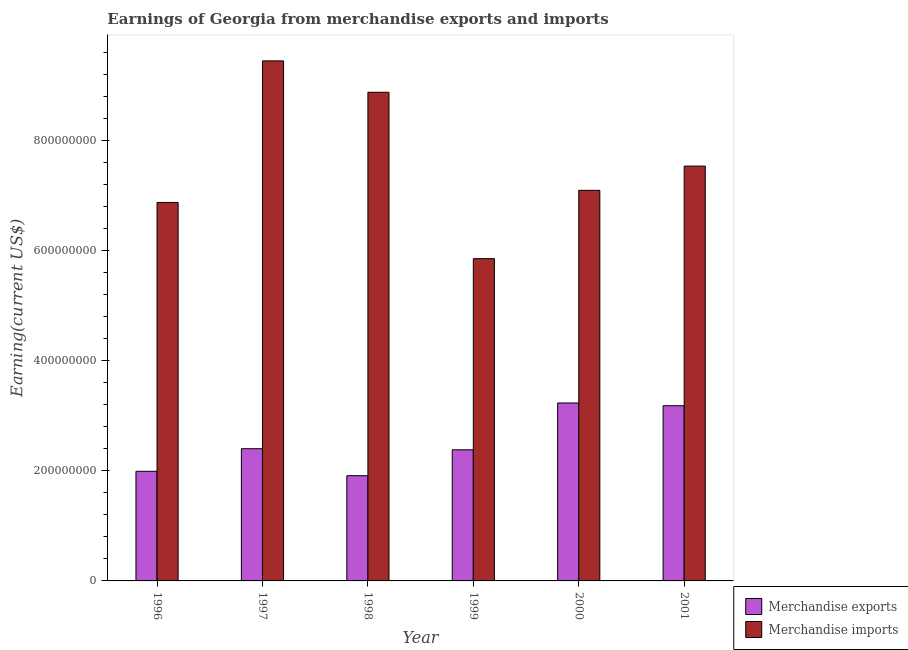How many groups of bars are there?
Offer a terse response. 6. Are the number of bars on each tick of the X-axis equal?
Your answer should be compact. Yes. How many bars are there on the 6th tick from the left?
Provide a short and direct response. 2. What is the earnings from merchandise imports in 1996?
Your response must be concise. 6.87e+08. Across all years, what is the maximum earnings from merchandise exports?
Your answer should be very brief. 3.23e+08. Across all years, what is the minimum earnings from merchandise imports?
Ensure brevity in your answer.  5.85e+08. In which year was the earnings from merchandise imports maximum?
Offer a terse response. 1997. In which year was the earnings from merchandise imports minimum?
Give a very brief answer. 1999. What is the total earnings from merchandise imports in the graph?
Your answer should be compact. 4.56e+09. What is the difference between the earnings from merchandise exports in 1999 and that in 2000?
Give a very brief answer. -8.50e+07. What is the difference between the earnings from merchandise imports in 1997 and the earnings from merchandise exports in 1999?
Your answer should be compact. 3.59e+08. What is the average earnings from merchandise imports per year?
Ensure brevity in your answer.  7.61e+08. In the year 1998, what is the difference between the earnings from merchandise imports and earnings from merchandise exports?
Provide a succinct answer. 0. In how many years, is the earnings from merchandise imports greater than 600000000 US$?
Ensure brevity in your answer.  5. What is the ratio of the earnings from merchandise imports in 1997 to that in 1999?
Your answer should be very brief. 1.61. Is the earnings from merchandise exports in 1999 less than that in 2001?
Your answer should be compact. Yes. What is the difference between the highest and the second highest earnings from merchandise imports?
Make the answer very short. 5.70e+07. What is the difference between the highest and the lowest earnings from merchandise exports?
Offer a terse response. 1.32e+08. In how many years, is the earnings from merchandise imports greater than the average earnings from merchandise imports taken over all years?
Your response must be concise. 2. How many bars are there?
Ensure brevity in your answer.  12. Are all the bars in the graph horizontal?
Provide a short and direct response. No. How many years are there in the graph?
Your answer should be compact. 6. Are the values on the major ticks of Y-axis written in scientific E-notation?
Your answer should be compact. No. How are the legend labels stacked?
Your response must be concise. Vertical. What is the title of the graph?
Offer a very short reply. Earnings of Georgia from merchandise exports and imports. What is the label or title of the X-axis?
Offer a very short reply. Year. What is the label or title of the Y-axis?
Offer a terse response. Earning(current US$). What is the Earning(current US$) of Merchandise exports in 1996?
Offer a terse response. 1.99e+08. What is the Earning(current US$) in Merchandise imports in 1996?
Keep it short and to the point. 6.87e+08. What is the Earning(current US$) of Merchandise exports in 1997?
Your response must be concise. 2.40e+08. What is the Earning(current US$) of Merchandise imports in 1997?
Keep it short and to the point. 9.44e+08. What is the Earning(current US$) in Merchandise exports in 1998?
Ensure brevity in your answer.  1.91e+08. What is the Earning(current US$) of Merchandise imports in 1998?
Make the answer very short. 8.87e+08. What is the Earning(current US$) in Merchandise exports in 1999?
Keep it short and to the point. 2.38e+08. What is the Earning(current US$) of Merchandise imports in 1999?
Give a very brief answer. 5.85e+08. What is the Earning(current US$) in Merchandise exports in 2000?
Ensure brevity in your answer.  3.23e+08. What is the Earning(current US$) in Merchandise imports in 2000?
Keep it short and to the point. 7.09e+08. What is the Earning(current US$) of Merchandise exports in 2001?
Ensure brevity in your answer.  3.18e+08. What is the Earning(current US$) of Merchandise imports in 2001?
Provide a succinct answer. 7.53e+08. Across all years, what is the maximum Earning(current US$) in Merchandise exports?
Keep it short and to the point. 3.23e+08. Across all years, what is the maximum Earning(current US$) of Merchandise imports?
Your response must be concise. 9.44e+08. Across all years, what is the minimum Earning(current US$) of Merchandise exports?
Make the answer very short. 1.91e+08. Across all years, what is the minimum Earning(current US$) of Merchandise imports?
Your answer should be very brief. 5.85e+08. What is the total Earning(current US$) of Merchandise exports in the graph?
Provide a short and direct response. 1.51e+09. What is the total Earning(current US$) in Merchandise imports in the graph?
Offer a terse response. 4.56e+09. What is the difference between the Earning(current US$) in Merchandise exports in 1996 and that in 1997?
Make the answer very short. -4.10e+07. What is the difference between the Earning(current US$) of Merchandise imports in 1996 and that in 1997?
Your answer should be compact. -2.57e+08. What is the difference between the Earning(current US$) in Merchandise exports in 1996 and that in 1998?
Give a very brief answer. 8.00e+06. What is the difference between the Earning(current US$) in Merchandise imports in 1996 and that in 1998?
Offer a very short reply. -2.00e+08. What is the difference between the Earning(current US$) of Merchandise exports in 1996 and that in 1999?
Offer a very short reply. -3.90e+07. What is the difference between the Earning(current US$) of Merchandise imports in 1996 and that in 1999?
Provide a short and direct response. 1.02e+08. What is the difference between the Earning(current US$) in Merchandise exports in 1996 and that in 2000?
Ensure brevity in your answer.  -1.24e+08. What is the difference between the Earning(current US$) of Merchandise imports in 1996 and that in 2000?
Offer a terse response. -2.20e+07. What is the difference between the Earning(current US$) in Merchandise exports in 1996 and that in 2001?
Your answer should be compact. -1.19e+08. What is the difference between the Earning(current US$) in Merchandise imports in 1996 and that in 2001?
Your response must be concise. -6.60e+07. What is the difference between the Earning(current US$) of Merchandise exports in 1997 and that in 1998?
Your answer should be compact. 4.90e+07. What is the difference between the Earning(current US$) of Merchandise imports in 1997 and that in 1998?
Your answer should be compact. 5.70e+07. What is the difference between the Earning(current US$) in Merchandise exports in 1997 and that in 1999?
Your answer should be very brief. 2.00e+06. What is the difference between the Earning(current US$) in Merchandise imports in 1997 and that in 1999?
Your answer should be very brief. 3.59e+08. What is the difference between the Earning(current US$) of Merchandise exports in 1997 and that in 2000?
Make the answer very short. -8.30e+07. What is the difference between the Earning(current US$) in Merchandise imports in 1997 and that in 2000?
Offer a terse response. 2.35e+08. What is the difference between the Earning(current US$) of Merchandise exports in 1997 and that in 2001?
Provide a short and direct response. -7.80e+07. What is the difference between the Earning(current US$) in Merchandise imports in 1997 and that in 2001?
Offer a terse response. 1.91e+08. What is the difference between the Earning(current US$) of Merchandise exports in 1998 and that in 1999?
Your answer should be very brief. -4.70e+07. What is the difference between the Earning(current US$) of Merchandise imports in 1998 and that in 1999?
Your answer should be compact. 3.02e+08. What is the difference between the Earning(current US$) of Merchandise exports in 1998 and that in 2000?
Your answer should be very brief. -1.32e+08. What is the difference between the Earning(current US$) of Merchandise imports in 1998 and that in 2000?
Keep it short and to the point. 1.78e+08. What is the difference between the Earning(current US$) in Merchandise exports in 1998 and that in 2001?
Your response must be concise. -1.27e+08. What is the difference between the Earning(current US$) in Merchandise imports in 1998 and that in 2001?
Make the answer very short. 1.34e+08. What is the difference between the Earning(current US$) of Merchandise exports in 1999 and that in 2000?
Make the answer very short. -8.50e+07. What is the difference between the Earning(current US$) in Merchandise imports in 1999 and that in 2000?
Your answer should be compact. -1.24e+08. What is the difference between the Earning(current US$) in Merchandise exports in 1999 and that in 2001?
Your answer should be compact. -8.00e+07. What is the difference between the Earning(current US$) in Merchandise imports in 1999 and that in 2001?
Keep it short and to the point. -1.68e+08. What is the difference between the Earning(current US$) in Merchandise imports in 2000 and that in 2001?
Your answer should be very brief. -4.40e+07. What is the difference between the Earning(current US$) of Merchandise exports in 1996 and the Earning(current US$) of Merchandise imports in 1997?
Offer a terse response. -7.45e+08. What is the difference between the Earning(current US$) of Merchandise exports in 1996 and the Earning(current US$) of Merchandise imports in 1998?
Your answer should be compact. -6.88e+08. What is the difference between the Earning(current US$) of Merchandise exports in 1996 and the Earning(current US$) of Merchandise imports in 1999?
Offer a terse response. -3.86e+08. What is the difference between the Earning(current US$) in Merchandise exports in 1996 and the Earning(current US$) in Merchandise imports in 2000?
Keep it short and to the point. -5.10e+08. What is the difference between the Earning(current US$) of Merchandise exports in 1996 and the Earning(current US$) of Merchandise imports in 2001?
Provide a short and direct response. -5.54e+08. What is the difference between the Earning(current US$) in Merchandise exports in 1997 and the Earning(current US$) in Merchandise imports in 1998?
Your answer should be compact. -6.47e+08. What is the difference between the Earning(current US$) in Merchandise exports in 1997 and the Earning(current US$) in Merchandise imports in 1999?
Make the answer very short. -3.45e+08. What is the difference between the Earning(current US$) in Merchandise exports in 1997 and the Earning(current US$) in Merchandise imports in 2000?
Make the answer very short. -4.69e+08. What is the difference between the Earning(current US$) in Merchandise exports in 1997 and the Earning(current US$) in Merchandise imports in 2001?
Ensure brevity in your answer.  -5.13e+08. What is the difference between the Earning(current US$) of Merchandise exports in 1998 and the Earning(current US$) of Merchandise imports in 1999?
Offer a very short reply. -3.94e+08. What is the difference between the Earning(current US$) in Merchandise exports in 1998 and the Earning(current US$) in Merchandise imports in 2000?
Give a very brief answer. -5.18e+08. What is the difference between the Earning(current US$) of Merchandise exports in 1998 and the Earning(current US$) of Merchandise imports in 2001?
Offer a terse response. -5.62e+08. What is the difference between the Earning(current US$) of Merchandise exports in 1999 and the Earning(current US$) of Merchandise imports in 2000?
Provide a succinct answer. -4.71e+08. What is the difference between the Earning(current US$) of Merchandise exports in 1999 and the Earning(current US$) of Merchandise imports in 2001?
Provide a short and direct response. -5.15e+08. What is the difference between the Earning(current US$) of Merchandise exports in 2000 and the Earning(current US$) of Merchandise imports in 2001?
Provide a succinct answer. -4.30e+08. What is the average Earning(current US$) of Merchandise exports per year?
Offer a terse response. 2.52e+08. What is the average Earning(current US$) in Merchandise imports per year?
Keep it short and to the point. 7.61e+08. In the year 1996, what is the difference between the Earning(current US$) of Merchandise exports and Earning(current US$) of Merchandise imports?
Your answer should be compact. -4.88e+08. In the year 1997, what is the difference between the Earning(current US$) of Merchandise exports and Earning(current US$) of Merchandise imports?
Keep it short and to the point. -7.04e+08. In the year 1998, what is the difference between the Earning(current US$) of Merchandise exports and Earning(current US$) of Merchandise imports?
Offer a very short reply. -6.96e+08. In the year 1999, what is the difference between the Earning(current US$) of Merchandise exports and Earning(current US$) of Merchandise imports?
Your answer should be compact. -3.47e+08. In the year 2000, what is the difference between the Earning(current US$) in Merchandise exports and Earning(current US$) in Merchandise imports?
Give a very brief answer. -3.86e+08. In the year 2001, what is the difference between the Earning(current US$) of Merchandise exports and Earning(current US$) of Merchandise imports?
Ensure brevity in your answer.  -4.35e+08. What is the ratio of the Earning(current US$) of Merchandise exports in 1996 to that in 1997?
Your answer should be very brief. 0.83. What is the ratio of the Earning(current US$) in Merchandise imports in 1996 to that in 1997?
Provide a short and direct response. 0.73. What is the ratio of the Earning(current US$) of Merchandise exports in 1996 to that in 1998?
Give a very brief answer. 1.04. What is the ratio of the Earning(current US$) of Merchandise imports in 1996 to that in 1998?
Provide a succinct answer. 0.77. What is the ratio of the Earning(current US$) in Merchandise exports in 1996 to that in 1999?
Your answer should be very brief. 0.84. What is the ratio of the Earning(current US$) of Merchandise imports in 1996 to that in 1999?
Give a very brief answer. 1.17. What is the ratio of the Earning(current US$) in Merchandise exports in 1996 to that in 2000?
Provide a succinct answer. 0.62. What is the ratio of the Earning(current US$) in Merchandise imports in 1996 to that in 2000?
Provide a succinct answer. 0.97. What is the ratio of the Earning(current US$) in Merchandise exports in 1996 to that in 2001?
Ensure brevity in your answer.  0.63. What is the ratio of the Earning(current US$) of Merchandise imports in 1996 to that in 2001?
Offer a very short reply. 0.91. What is the ratio of the Earning(current US$) of Merchandise exports in 1997 to that in 1998?
Ensure brevity in your answer.  1.26. What is the ratio of the Earning(current US$) of Merchandise imports in 1997 to that in 1998?
Offer a very short reply. 1.06. What is the ratio of the Earning(current US$) in Merchandise exports in 1997 to that in 1999?
Ensure brevity in your answer.  1.01. What is the ratio of the Earning(current US$) of Merchandise imports in 1997 to that in 1999?
Your answer should be very brief. 1.61. What is the ratio of the Earning(current US$) of Merchandise exports in 1997 to that in 2000?
Ensure brevity in your answer.  0.74. What is the ratio of the Earning(current US$) in Merchandise imports in 1997 to that in 2000?
Your response must be concise. 1.33. What is the ratio of the Earning(current US$) in Merchandise exports in 1997 to that in 2001?
Keep it short and to the point. 0.75. What is the ratio of the Earning(current US$) of Merchandise imports in 1997 to that in 2001?
Make the answer very short. 1.25. What is the ratio of the Earning(current US$) in Merchandise exports in 1998 to that in 1999?
Ensure brevity in your answer.  0.8. What is the ratio of the Earning(current US$) of Merchandise imports in 1998 to that in 1999?
Keep it short and to the point. 1.52. What is the ratio of the Earning(current US$) of Merchandise exports in 1998 to that in 2000?
Provide a short and direct response. 0.59. What is the ratio of the Earning(current US$) of Merchandise imports in 1998 to that in 2000?
Your answer should be compact. 1.25. What is the ratio of the Earning(current US$) in Merchandise exports in 1998 to that in 2001?
Make the answer very short. 0.6. What is the ratio of the Earning(current US$) of Merchandise imports in 1998 to that in 2001?
Offer a very short reply. 1.18. What is the ratio of the Earning(current US$) of Merchandise exports in 1999 to that in 2000?
Ensure brevity in your answer.  0.74. What is the ratio of the Earning(current US$) in Merchandise imports in 1999 to that in 2000?
Make the answer very short. 0.83. What is the ratio of the Earning(current US$) of Merchandise exports in 1999 to that in 2001?
Provide a short and direct response. 0.75. What is the ratio of the Earning(current US$) in Merchandise imports in 1999 to that in 2001?
Your answer should be very brief. 0.78. What is the ratio of the Earning(current US$) in Merchandise exports in 2000 to that in 2001?
Offer a very short reply. 1.02. What is the ratio of the Earning(current US$) in Merchandise imports in 2000 to that in 2001?
Offer a very short reply. 0.94. What is the difference between the highest and the second highest Earning(current US$) in Merchandise exports?
Provide a succinct answer. 5.00e+06. What is the difference between the highest and the second highest Earning(current US$) in Merchandise imports?
Your response must be concise. 5.70e+07. What is the difference between the highest and the lowest Earning(current US$) of Merchandise exports?
Make the answer very short. 1.32e+08. What is the difference between the highest and the lowest Earning(current US$) in Merchandise imports?
Offer a terse response. 3.59e+08. 